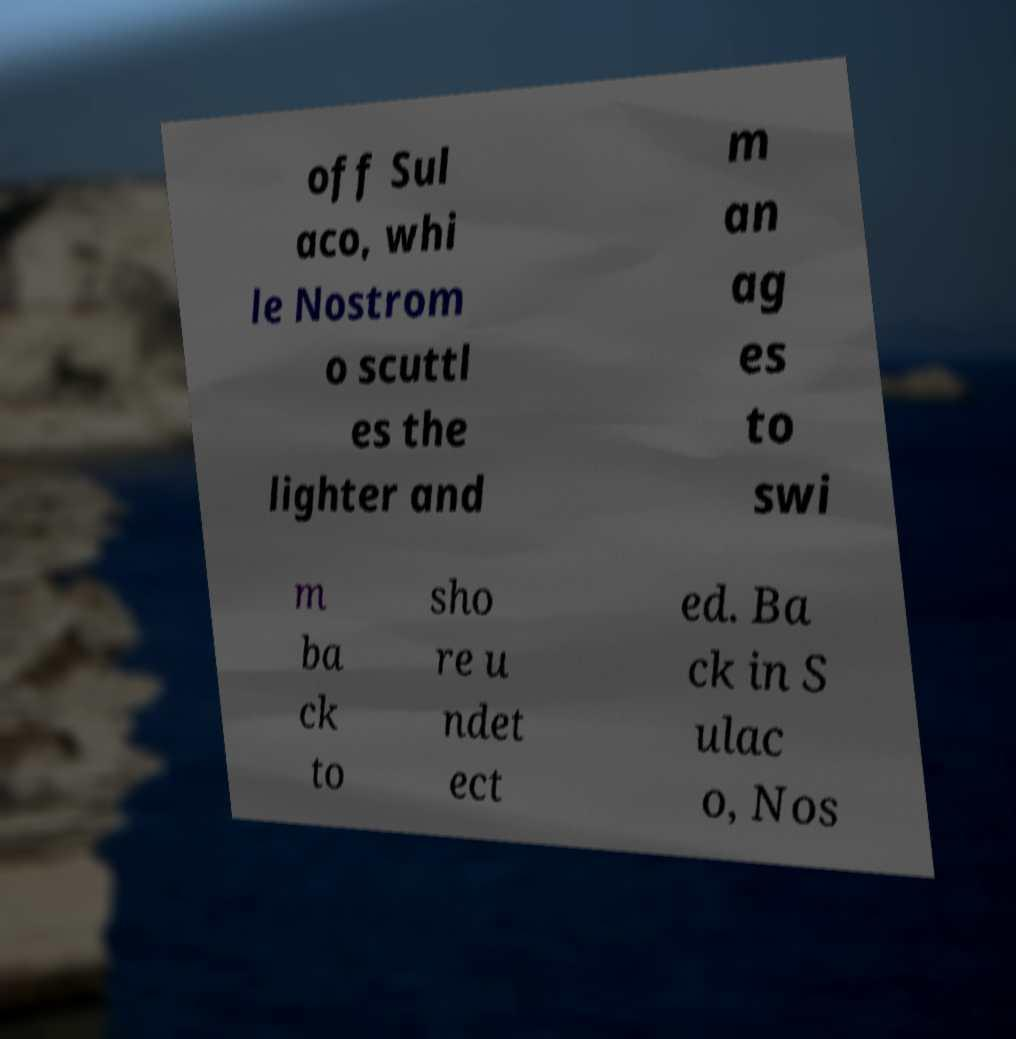For documentation purposes, I need the text within this image transcribed. Could you provide that? off Sul aco, whi le Nostrom o scuttl es the lighter and m an ag es to swi m ba ck to sho re u ndet ect ed. Ba ck in S ulac o, Nos 